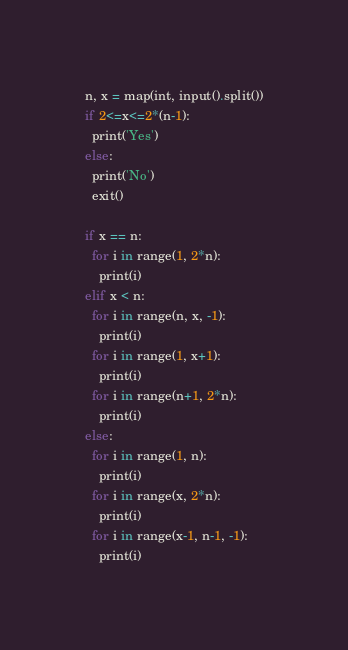<code> <loc_0><loc_0><loc_500><loc_500><_Python_>n, x = map(int, input().split())
if 2<=x<=2*(n-1):
  print('Yes')
else:
  print('No')
  exit()
  
if x == n:
  for i in range(1, 2*n):
    print(i)
elif x < n:
  for i in range(n, x, -1):
    print(i)
  for i in range(1, x+1):
    print(i)
  for i in range(n+1, 2*n):
    print(i)
else:
  for i in range(1, n):
    print(i)
  for i in range(x, 2*n):
    print(i)
  for i in range(x-1, n-1, -1):
    print(i)
</code> 